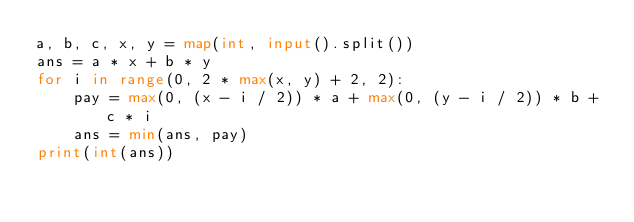Convert code to text. <code><loc_0><loc_0><loc_500><loc_500><_Python_>a, b, c, x, y = map(int, input().split())
ans = a * x + b * y
for i in range(0, 2 * max(x, y) + 2, 2):
    pay = max(0, (x - i / 2)) * a + max(0, (y - i / 2)) * b + c * i
    ans = min(ans, pay)
print(int(ans))
</code> 